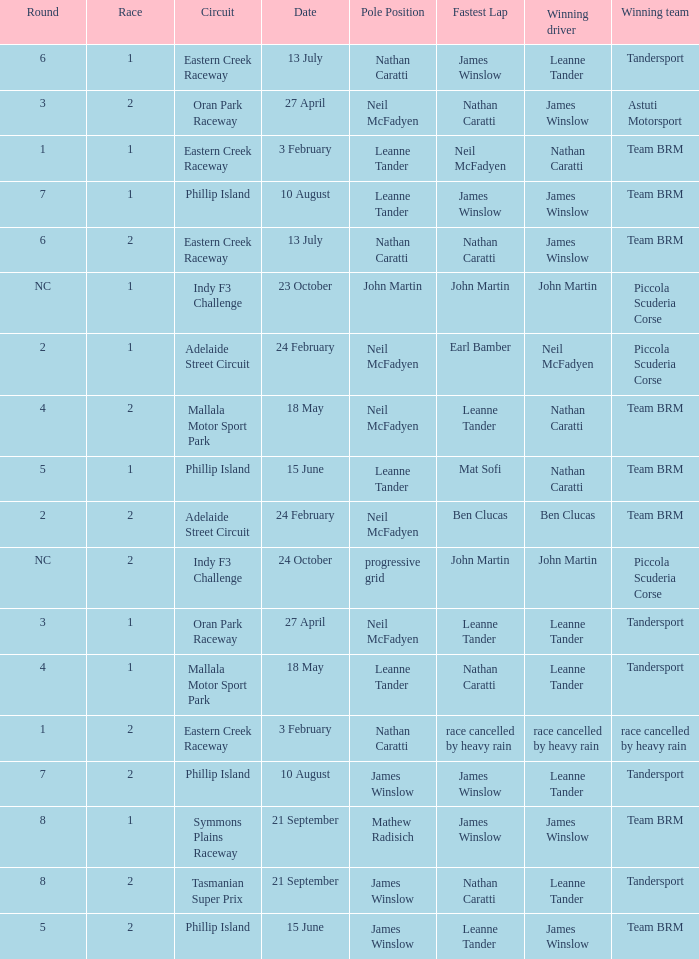Which race number in the indy f3 challenge course featured john martin in the leading position? 1.0. 